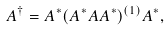<formula> <loc_0><loc_0><loc_500><loc_500>A ^ { \dag } = A ^ { \ast } ( A ^ { \ast } A A ^ { \ast } ) ^ { ( 1 ) } A ^ { \ast } ,</formula> 